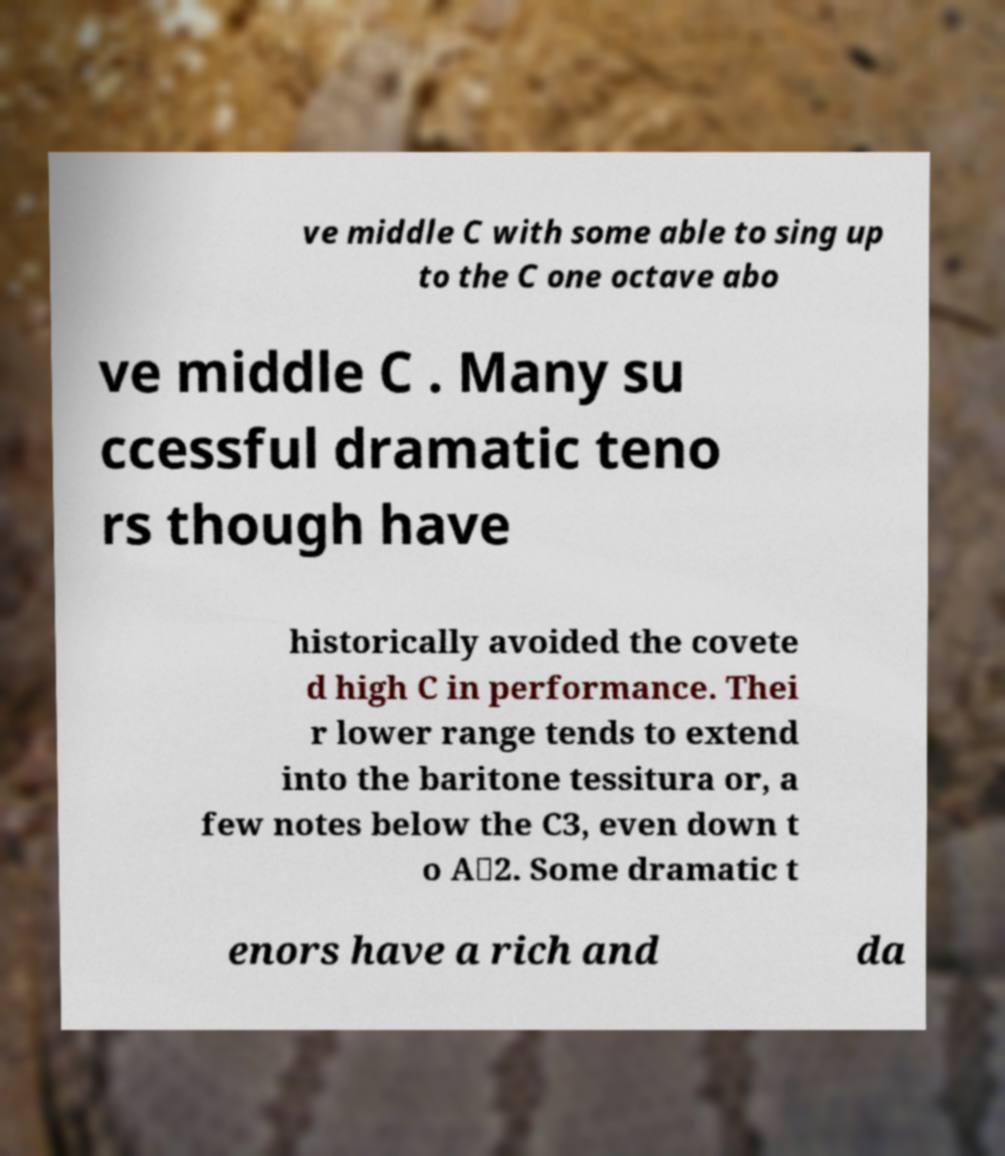For documentation purposes, I need the text within this image transcribed. Could you provide that? ve middle C with some able to sing up to the C one octave abo ve middle C . Many su ccessful dramatic teno rs though have historically avoided the covete d high C in performance. Thei r lower range tends to extend into the baritone tessitura or, a few notes below the C3, even down t o A♭2. Some dramatic t enors have a rich and da 